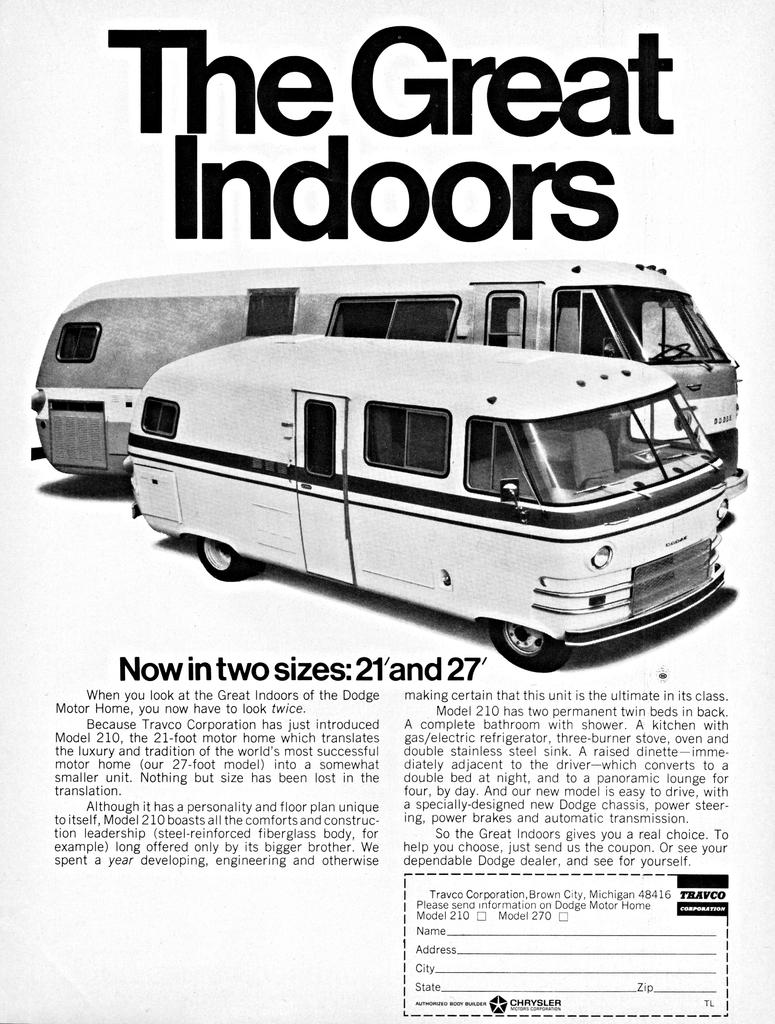Provide a one-sentence caption for the provided image. A magazine page that titles The Great Outdoors with pictures of old school RVs and featuring a phrase that reads Now in two sizes: 21' and 27'. 